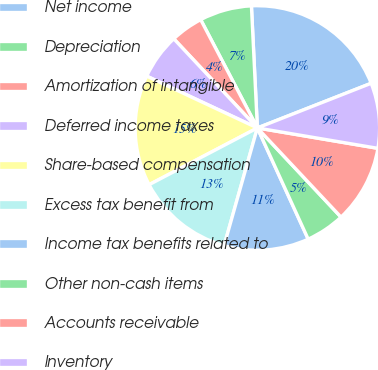<chart> <loc_0><loc_0><loc_500><loc_500><pie_chart><fcel>Net income<fcel>Depreciation<fcel>Amortization of intangible<fcel>Deferred income taxes<fcel>Share-based compensation<fcel>Excess tax benefit from<fcel>Income tax benefits related to<fcel>Other non-cash items<fcel>Accounts receivable<fcel>Inventory<nl><fcel>19.82%<fcel>6.9%<fcel>4.31%<fcel>6.04%<fcel>14.65%<fcel>12.93%<fcel>11.21%<fcel>5.17%<fcel>10.34%<fcel>8.62%<nl></chart> 